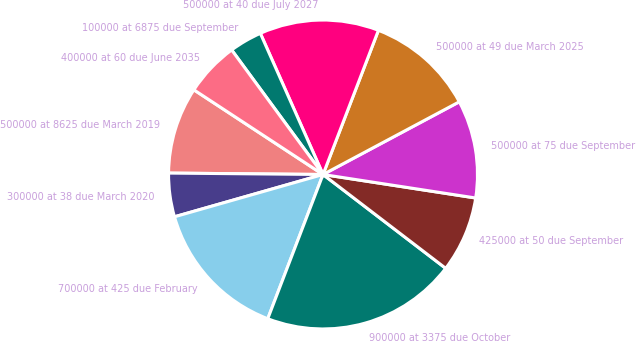Convert chart to OTSL. <chart><loc_0><loc_0><loc_500><loc_500><pie_chart><fcel>500000 at 8625 due March 2019<fcel>300000 at 38 due March 2020<fcel>700000 at 425 due February<fcel>900000 at 3375 due October<fcel>425000 at 50 due September<fcel>500000 at 75 due September<fcel>500000 at 49 due March 2025<fcel>500000 at 40 due July 2027<fcel>100000 at 6875 due September<fcel>400000 at 60 due June 2035<nl><fcel>9.09%<fcel>4.56%<fcel>14.76%<fcel>20.43%<fcel>7.96%<fcel>10.23%<fcel>11.36%<fcel>12.49%<fcel>3.42%<fcel>5.69%<nl></chart> 